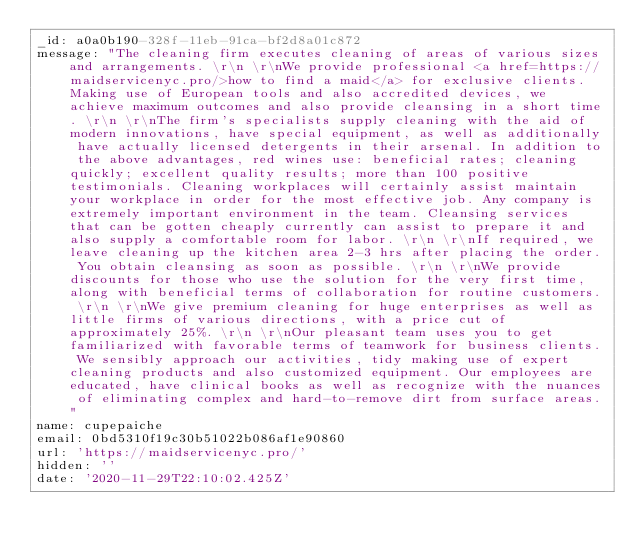<code> <loc_0><loc_0><loc_500><loc_500><_YAML_>_id: a0a0b190-328f-11eb-91ca-bf2d8a01c872
message: "The cleaning firm executes cleaning of areas of various sizes and arrangements. \r\n \r\nWe provide professional <a href=https://maidservicenyc.pro/>how to find a maid</a> for exclusive clients. Making use of European tools and also accredited devices, we achieve maximum outcomes and also provide cleansing in a short time. \r\n \r\nThe firm's specialists supply cleaning with the aid of modern innovations, have special equipment, as well as additionally have actually licensed detergents in their arsenal. In addition to the above advantages, red wines use: beneficial rates; cleaning quickly; excellent quality results; more than 100 positive testimonials. Cleaning workplaces will certainly assist maintain your workplace in order for the most effective job. Any company is extremely important environment in the team. Cleansing services that can be gotten cheaply currently can assist to prepare it and also supply a comfortable room for labor. \r\n \r\nIf required, we leave cleaning up the kitchen area 2-3 hrs after placing the order. You obtain cleansing as soon as possible. \r\n \r\nWe provide discounts for those who use the solution for the very first time, along with beneficial terms of collaboration for routine customers. \r\n \r\nWe give premium cleaning for huge enterprises as well as little firms of various directions, with a price cut of approximately 25%. \r\n \r\nOur pleasant team uses you to get familiarized with favorable terms of teamwork for business clients. We sensibly approach our activities, tidy making use of expert cleaning products and also customized equipment. Our employees are educated, have clinical books as well as recognize with the nuances of eliminating complex and hard-to-remove dirt from surface areas."
name: cupepaiche
email: 0bd5310f19c30b51022b086af1e90860
url: 'https://maidservicenyc.pro/'
hidden: ''
date: '2020-11-29T22:10:02.425Z'
</code> 